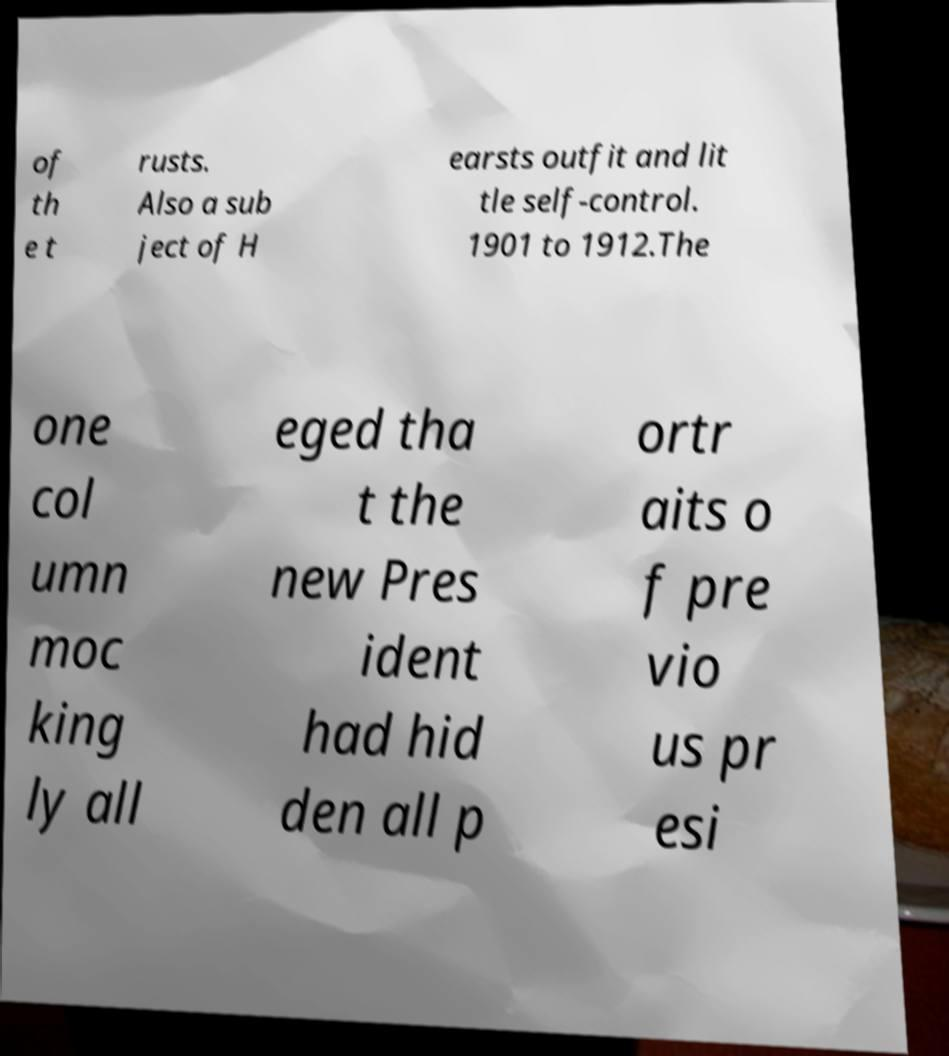What messages or text are displayed in this image? I need them in a readable, typed format. of th e t rusts. Also a sub ject of H earsts outfit and lit tle self-control. 1901 to 1912.The one col umn moc king ly all eged tha t the new Pres ident had hid den all p ortr aits o f pre vio us pr esi 